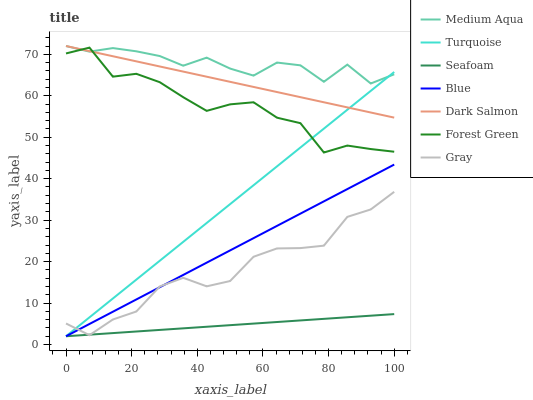Does Gray have the minimum area under the curve?
Answer yes or no. No. Does Gray have the maximum area under the curve?
Answer yes or no. No. Is Gray the smoothest?
Answer yes or no. No. Is Gray the roughest?
Answer yes or no. No. Does Gray have the lowest value?
Answer yes or no. No. Does Gray have the highest value?
Answer yes or no. No. Is Seafoam less than Medium Aqua?
Answer yes or no. Yes. Is Medium Aqua greater than Seafoam?
Answer yes or no. Yes. Does Seafoam intersect Medium Aqua?
Answer yes or no. No. 